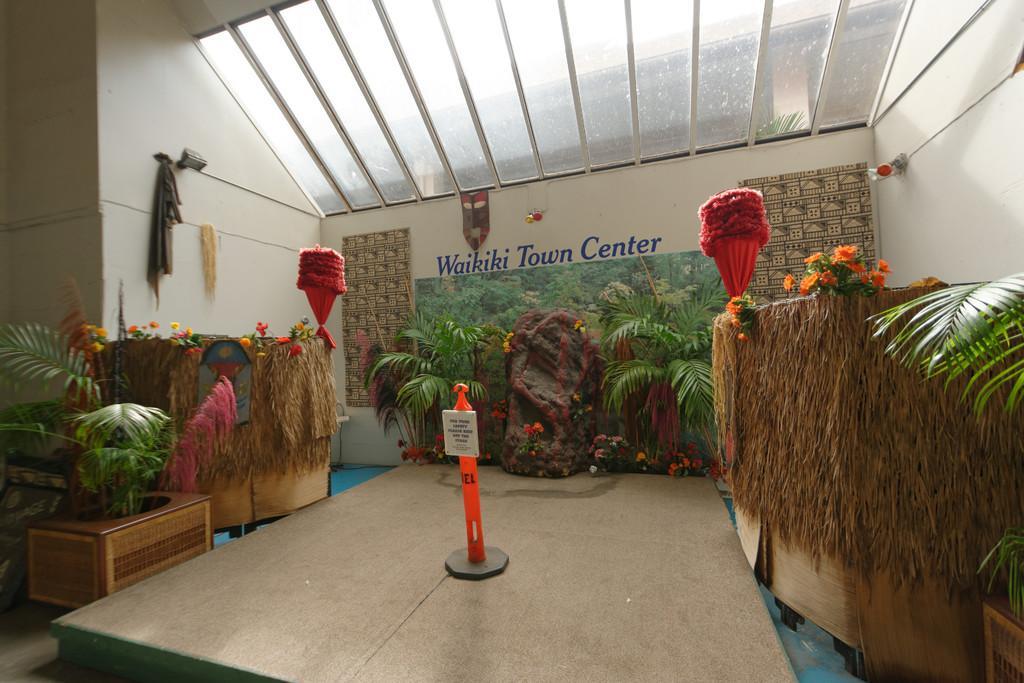Describe this image in one or two sentences. In this picture there is a board on the pole and there is a text on the board. On the left and on the right side of the image there are plants and flowers. At the back there are plants and flowers. There is a text on the wall and there are lights on the wall. At the top there is a glass roof. 